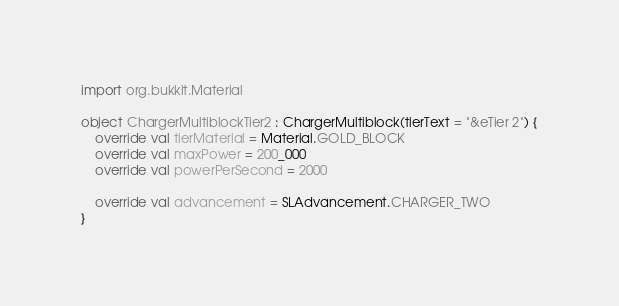<code> <loc_0><loc_0><loc_500><loc_500><_Kotlin_>import org.bukkit.Material

object ChargerMultiblockTier2 : ChargerMultiblock(tierText = "&eTier 2") {
    override val tierMaterial = Material.GOLD_BLOCK
    override val maxPower = 200_000
    override val powerPerSecond = 2000

    override val advancement = SLAdvancement.CHARGER_TWO
}
</code> 